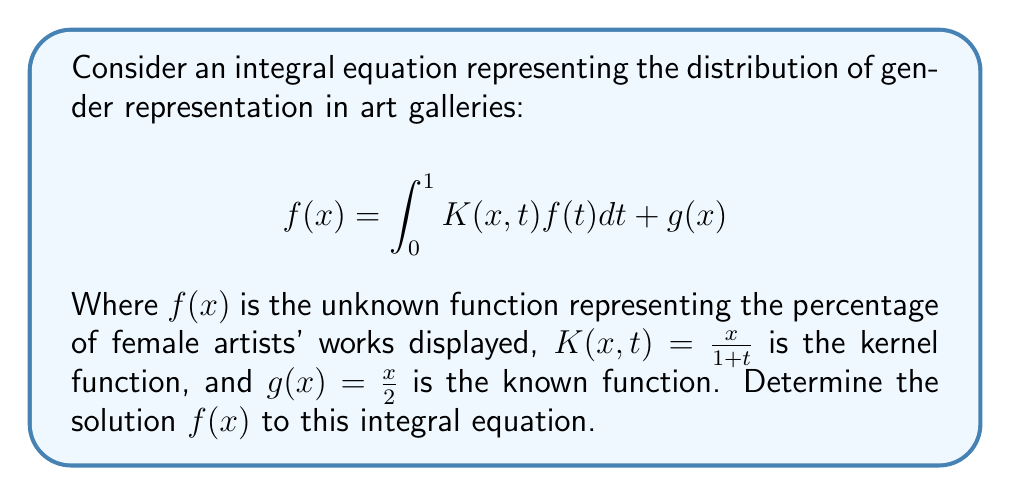Help me with this question. To solve this integral equation, we'll use the method of successive approximations:

1) Start with an initial guess: $f_0(x) = g(x) = \frac{x}{2}$

2) Apply the iteration formula:
   $$f_{n+1}(x) = \int_0^1 K(x,t)f_n(t)dt + g(x)$$

3) First iteration:
   $$f_1(x) = \int_0^1 \frac{x}{1+t} \cdot \frac{t}{2}dt + \frac{x}{2}$$
   $$= \frac{x}{2}\int_0^1 \frac{t}{1+t}dt + \frac{x}{2}$$
   $$= \frac{x}{2}[(t - \ln(1+t))]_0^1 + \frac{x}{2}$$
   $$= \frac{x}{2}(1 - \ln 2) + \frac{x}{2} = x(1 - \frac{\ln 2}{2})$$

4) Second iteration:
   $$f_2(x) = \int_0^1 \frac{x}{1+t} \cdot t(1 - \frac{\ln 2}{2})dt + \frac{x}{2}$$
   $$= x(1 - \frac{\ln 2}{2})\int_0^1 \frac{t}{1+t}dt + \frac{x}{2}$$
   $$= x(1 - \frac{\ln 2}{2})(1 - \ln 2) + \frac{x}{2}$$

5) Continuing this process, we can see that the solution converges to:
   $$f(x) = \frac{x}{2-\ln 2}$$

6) Verify the solution:
   $$\int_0^1 K(x,t)f(t)dt + g(x) = \int_0^1 \frac{x}{1+t} \cdot \frac{t}{2-\ln 2}dt + \frac{x}{2}$$
   $$= \frac{x}{2-\ln 2}\int_0^1 \frac{t}{1+t}dt + \frac{x}{2}$$
   $$= \frac{x}{2-\ln 2}(1 - \ln 2) + \frac{x}{2} = \frac{x}{2-\ln 2} = f(x)$$

Thus, the solution satisfies the integral equation.
Answer: $f(x) = \frac{x}{2-\ln 2}$ 